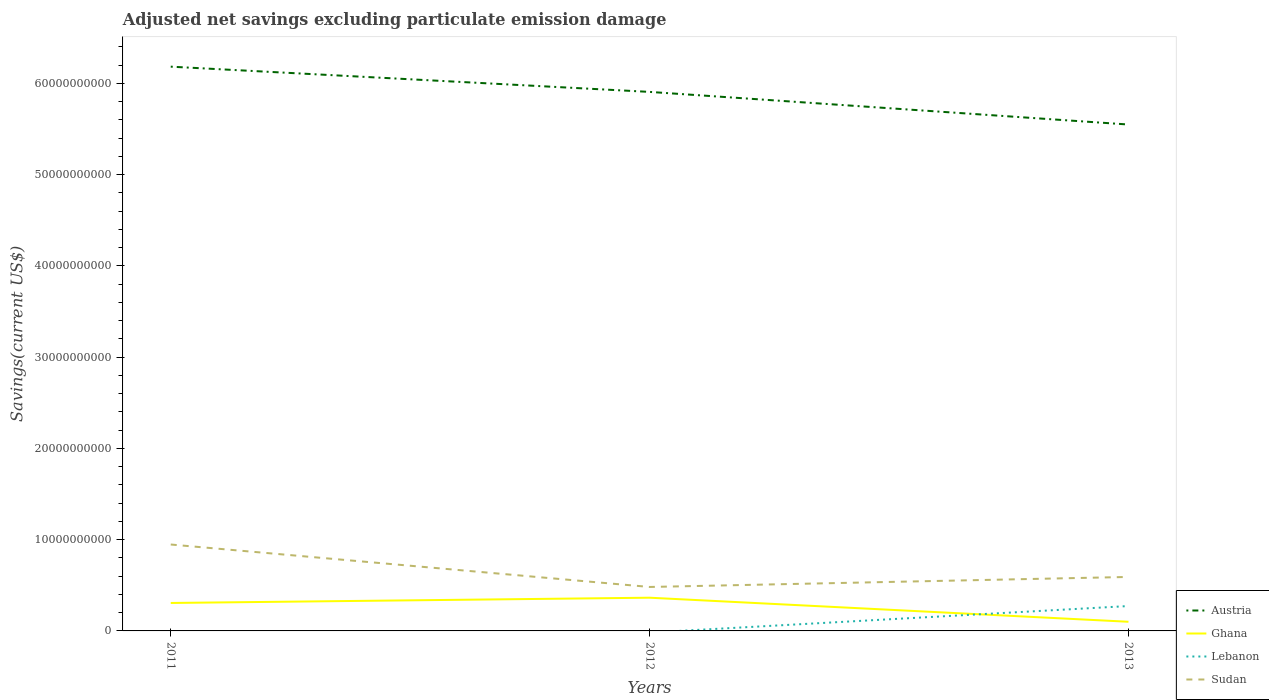How many different coloured lines are there?
Give a very brief answer. 4. Is the number of lines equal to the number of legend labels?
Provide a succinct answer. No. Across all years, what is the maximum adjusted net savings in Ghana?
Give a very brief answer. 1.00e+09. What is the total adjusted net savings in Ghana in the graph?
Keep it short and to the point. 2.06e+09. What is the difference between the highest and the second highest adjusted net savings in Sudan?
Your response must be concise. 4.65e+09. What is the difference between the highest and the lowest adjusted net savings in Ghana?
Give a very brief answer. 2. How many lines are there?
Keep it short and to the point. 4. How many years are there in the graph?
Make the answer very short. 3. Does the graph contain grids?
Offer a very short reply. No. Where does the legend appear in the graph?
Your answer should be compact. Bottom right. How many legend labels are there?
Your answer should be very brief. 4. How are the legend labels stacked?
Ensure brevity in your answer.  Vertical. What is the title of the graph?
Offer a terse response. Adjusted net savings excluding particulate emission damage. What is the label or title of the Y-axis?
Ensure brevity in your answer.  Savings(current US$). What is the Savings(current US$) of Austria in 2011?
Provide a short and direct response. 6.18e+1. What is the Savings(current US$) in Ghana in 2011?
Your answer should be compact. 3.06e+09. What is the Savings(current US$) in Sudan in 2011?
Your response must be concise. 9.47e+09. What is the Savings(current US$) of Austria in 2012?
Make the answer very short. 5.91e+1. What is the Savings(current US$) in Ghana in 2012?
Offer a terse response. 3.64e+09. What is the Savings(current US$) of Lebanon in 2012?
Give a very brief answer. 0. What is the Savings(current US$) in Sudan in 2012?
Keep it short and to the point. 4.82e+09. What is the Savings(current US$) of Austria in 2013?
Offer a terse response. 5.55e+1. What is the Savings(current US$) of Ghana in 2013?
Make the answer very short. 1.00e+09. What is the Savings(current US$) of Lebanon in 2013?
Provide a short and direct response. 2.73e+09. What is the Savings(current US$) of Sudan in 2013?
Offer a very short reply. 5.91e+09. Across all years, what is the maximum Savings(current US$) of Austria?
Provide a succinct answer. 6.18e+1. Across all years, what is the maximum Savings(current US$) in Ghana?
Provide a succinct answer. 3.64e+09. Across all years, what is the maximum Savings(current US$) of Lebanon?
Offer a terse response. 2.73e+09. Across all years, what is the maximum Savings(current US$) in Sudan?
Offer a terse response. 9.47e+09. Across all years, what is the minimum Savings(current US$) in Austria?
Provide a succinct answer. 5.55e+1. Across all years, what is the minimum Savings(current US$) of Ghana?
Keep it short and to the point. 1.00e+09. Across all years, what is the minimum Savings(current US$) in Sudan?
Make the answer very short. 4.82e+09. What is the total Savings(current US$) of Austria in the graph?
Give a very brief answer. 1.76e+11. What is the total Savings(current US$) in Ghana in the graph?
Your answer should be compact. 7.71e+09. What is the total Savings(current US$) of Lebanon in the graph?
Offer a very short reply. 2.73e+09. What is the total Savings(current US$) of Sudan in the graph?
Provide a short and direct response. 2.02e+1. What is the difference between the Savings(current US$) of Austria in 2011 and that in 2012?
Offer a very short reply. 2.76e+09. What is the difference between the Savings(current US$) in Ghana in 2011 and that in 2012?
Make the answer very short. -5.76e+08. What is the difference between the Savings(current US$) of Sudan in 2011 and that in 2012?
Ensure brevity in your answer.  4.65e+09. What is the difference between the Savings(current US$) in Austria in 2011 and that in 2013?
Provide a short and direct response. 6.34e+09. What is the difference between the Savings(current US$) of Ghana in 2011 and that in 2013?
Provide a short and direct response. 2.06e+09. What is the difference between the Savings(current US$) of Sudan in 2011 and that in 2013?
Keep it short and to the point. 3.55e+09. What is the difference between the Savings(current US$) in Austria in 2012 and that in 2013?
Your answer should be very brief. 3.57e+09. What is the difference between the Savings(current US$) in Ghana in 2012 and that in 2013?
Your response must be concise. 2.64e+09. What is the difference between the Savings(current US$) in Sudan in 2012 and that in 2013?
Give a very brief answer. -1.10e+09. What is the difference between the Savings(current US$) in Austria in 2011 and the Savings(current US$) in Ghana in 2012?
Offer a terse response. 5.82e+1. What is the difference between the Savings(current US$) of Austria in 2011 and the Savings(current US$) of Sudan in 2012?
Keep it short and to the point. 5.70e+1. What is the difference between the Savings(current US$) of Ghana in 2011 and the Savings(current US$) of Sudan in 2012?
Make the answer very short. -1.75e+09. What is the difference between the Savings(current US$) in Austria in 2011 and the Savings(current US$) in Ghana in 2013?
Your response must be concise. 6.08e+1. What is the difference between the Savings(current US$) of Austria in 2011 and the Savings(current US$) of Lebanon in 2013?
Your answer should be compact. 5.91e+1. What is the difference between the Savings(current US$) in Austria in 2011 and the Savings(current US$) in Sudan in 2013?
Your response must be concise. 5.59e+1. What is the difference between the Savings(current US$) in Ghana in 2011 and the Savings(current US$) in Lebanon in 2013?
Offer a terse response. 3.37e+08. What is the difference between the Savings(current US$) in Ghana in 2011 and the Savings(current US$) in Sudan in 2013?
Your answer should be compact. -2.85e+09. What is the difference between the Savings(current US$) in Austria in 2012 and the Savings(current US$) in Ghana in 2013?
Offer a very short reply. 5.81e+1. What is the difference between the Savings(current US$) of Austria in 2012 and the Savings(current US$) of Lebanon in 2013?
Ensure brevity in your answer.  5.63e+1. What is the difference between the Savings(current US$) in Austria in 2012 and the Savings(current US$) in Sudan in 2013?
Your answer should be very brief. 5.31e+1. What is the difference between the Savings(current US$) of Ghana in 2012 and the Savings(current US$) of Lebanon in 2013?
Keep it short and to the point. 9.12e+08. What is the difference between the Savings(current US$) of Ghana in 2012 and the Savings(current US$) of Sudan in 2013?
Ensure brevity in your answer.  -2.28e+09. What is the average Savings(current US$) in Austria per year?
Your answer should be very brief. 5.88e+1. What is the average Savings(current US$) of Ghana per year?
Provide a succinct answer. 2.57e+09. What is the average Savings(current US$) of Lebanon per year?
Offer a very short reply. 9.09e+08. What is the average Savings(current US$) of Sudan per year?
Make the answer very short. 6.73e+09. In the year 2011, what is the difference between the Savings(current US$) in Austria and Savings(current US$) in Ghana?
Give a very brief answer. 5.88e+1. In the year 2011, what is the difference between the Savings(current US$) of Austria and Savings(current US$) of Sudan?
Provide a short and direct response. 5.24e+1. In the year 2011, what is the difference between the Savings(current US$) in Ghana and Savings(current US$) in Sudan?
Your response must be concise. -6.40e+09. In the year 2012, what is the difference between the Savings(current US$) of Austria and Savings(current US$) of Ghana?
Ensure brevity in your answer.  5.54e+1. In the year 2012, what is the difference between the Savings(current US$) in Austria and Savings(current US$) in Sudan?
Offer a very short reply. 5.42e+1. In the year 2012, what is the difference between the Savings(current US$) in Ghana and Savings(current US$) in Sudan?
Provide a succinct answer. -1.18e+09. In the year 2013, what is the difference between the Savings(current US$) of Austria and Savings(current US$) of Ghana?
Ensure brevity in your answer.  5.45e+1. In the year 2013, what is the difference between the Savings(current US$) in Austria and Savings(current US$) in Lebanon?
Ensure brevity in your answer.  5.28e+1. In the year 2013, what is the difference between the Savings(current US$) of Austria and Savings(current US$) of Sudan?
Your response must be concise. 4.96e+1. In the year 2013, what is the difference between the Savings(current US$) of Ghana and Savings(current US$) of Lebanon?
Keep it short and to the point. -1.72e+09. In the year 2013, what is the difference between the Savings(current US$) in Ghana and Savings(current US$) in Sudan?
Provide a short and direct response. -4.91e+09. In the year 2013, what is the difference between the Savings(current US$) of Lebanon and Savings(current US$) of Sudan?
Provide a succinct answer. -3.19e+09. What is the ratio of the Savings(current US$) of Austria in 2011 to that in 2012?
Make the answer very short. 1.05. What is the ratio of the Savings(current US$) of Ghana in 2011 to that in 2012?
Give a very brief answer. 0.84. What is the ratio of the Savings(current US$) of Sudan in 2011 to that in 2012?
Your response must be concise. 1.97. What is the ratio of the Savings(current US$) in Austria in 2011 to that in 2013?
Keep it short and to the point. 1.11. What is the ratio of the Savings(current US$) in Ghana in 2011 to that in 2013?
Ensure brevity in your answer.  3.05. What is the ratio of the Savings(current US$) of Sudan in 2011 to that in 2013?
Your response must be concise. 1.6. What is the ratio of the Savings(current US$) of Austria in 2012 to that in 2013?
Your response must be concise. 1.06. What is the ratio of the Savings(current US$) of Ghana in 2012 to that in 2013?
Provide a succinct answer. 3.63. What is the ratio of the Savings(current US$) in Sudan in 2012 to that in 2013?
Offer a very short reply. 0.81. What is the difference between the highest and the second highest Savings(current US$) in Austria?
Ensure brevity in your answer.  2.76e+09. What is the difference between the highest and the second highest Savings(current US$) in Ghana?
Your answer should be compact. 5.76e+08. What is the difference between the highest and the second highest Savings(current US$) of Sudan?
Offer a terse response. 3.55e+09. What is the difference between the highest and the lowest Savings(current US$) of Austria?
Your answer should be very brief. 6.34e+09. What is the difference between the highest and the lowest Savings(current US$) in Ghana?
Your answer should be compact. 2.64e+09. What is the difference between the highest and the lowest Savings(current US$) in Lebanon?
Ensure brevity in your answer.  2.73e+09. What is the difference between the highest and the lowest Savings(current US$) in Sudan?
Offer a very short reply. 4.65e+09. 